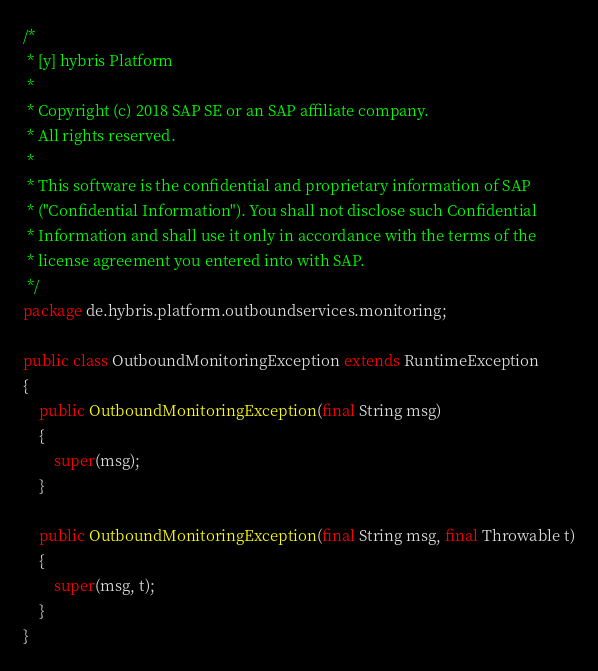Convert code to text. <code><loc_0><loc_0><loc_500><loc_500><_Java_>/*
 * [y] hybris Platform
 *
 * Copyright (c) 2018 SAP SE or an SAP affiliate company.
 * All rights reserved.
 *
 * This software is the confidential and proprietary information of SAP
 * ("Confidential Information"). You shall not disclose such Confidential
 * Information and shall use it only in accordance with the terms of the
 * license agreement you entered into with SAP.
 */
package de.hybris.platform.outboundservices.monitoring;

public class OutboundMonitoringException extends RuntimeException
{
	public OutboundMonitoringException(final String msg)
	{
		super(msg);
	}

	public OutboundMonitoringException(final String msg, final Throwable t)
	{
		super(msg, t);
	}
}
</code> 